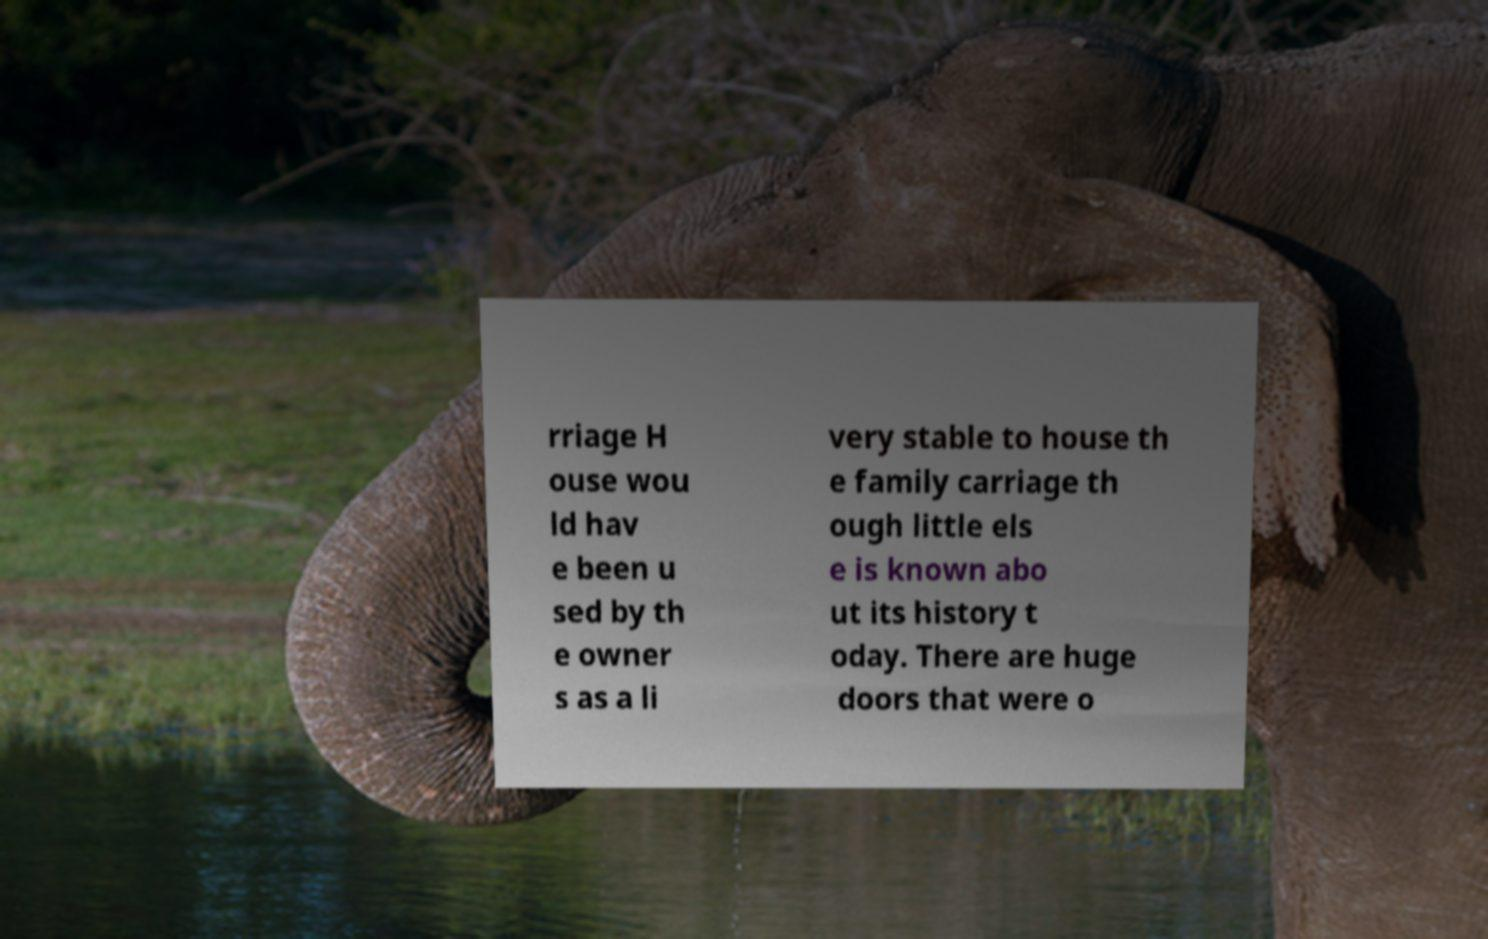I need the written content from this picture converted into text. Can you do that? rriage H ouse wou ld hav e been u sed by th e owner s as a li very stable to house th e family carriage th ough little els e is known abo ut its history t oday. There are huge doors that were o 